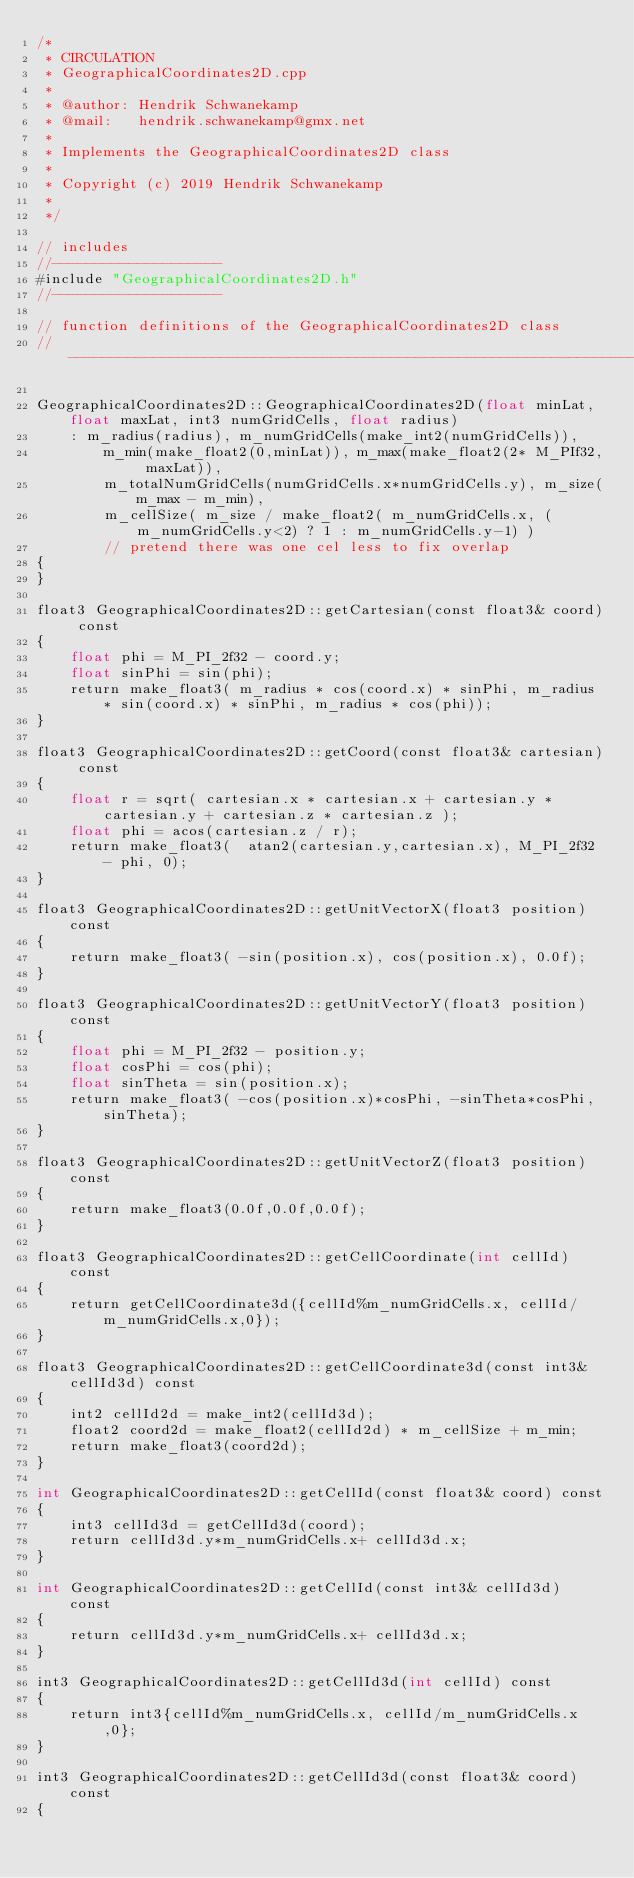Convert code to text. <code><loc_0><loc_0><loc_500><loc_500><_Cuda_>/*
 * CIRCULATION
 * GeographicalCoordinates2D.cpp
 *
 * @author: Hendrik Schwanekamp
 * @mail:   hendrik.schwanekamp@gmx.net
 *
 * Implements the GeographicalCoordinates2D class
 *
 * Copyright (c) 2019 Hendrik Schwanekamp
 *
 */

// includes
//--------------------
#include "GeographicalCoordinates2D.h"
//--------------------

// function definitions of the GeographicalCoordinates2D class
//-------------------------------------------------------------------

GeographicalCoordinates2D::GeographicalCoordinates2D(float minLat, float maxLat, int3 numGridCells, float radius)
    : m_radius(radius), m_numGridCells(make_int2(numGridCells)),
        m_min(make_float2(0,minLat)), m_max(make_float2(2* M_PIf32, maxLat)),
        m_totalNumGridCells(numGridCells.x*numGridCells.y), m_size(m_max - m_min),
        m_cellSize( m_size / make_float2( m_numGridCells.x, (m_numGridCells.y<2) ? 1 : m_numGridCells.y-1) )
        // pretend there was one cel less to fix overlap
{
}

float3 GeographicalCoordinates2D::getCartesian(const float3& coord) const
{
    float phi = M_PI_2f32 - coord.y;
    float sinPhi = sin(phi);
    return make_float3( m_radius * cos(coord.x) * sinPhi, m_radius * sin(coord.x) * sinPhi, m_radius * cos(phi));
}

float3 GeographicalCoordinates2D::getCoord(const float3& cartesian) const
{
    float r = sqrt( cartesian.x * cartesian.x + cartesian.y * cartesian.y + cartesian.z * cartesian.z );
    float phi = acos(cartesian.z / r);
    return make_float3(  atan2(cartesian.y,cartesian.x), M_PI_2f32 - phi, 0);
}

float3 GeographicalCoordinates2D::getUnitVectorX(float3 position) const
{
    return make_float3( -sin(position.x), cos(position.x), 0.0f);
}

float3 GeographicalCoordinates2D::getUnitVectorY(float3 position) const
{
    float phi = M_PI_2f32 - position.y;
    float cosPhi = cos(phi);
    float sinTheta = sin(position.x);
    return make_float3( -cos(position.x)*cosPhi, -sinTheta*cosPhi, sinTheta);
}

float3 GeographicalCoordinates2D::getUnitVectorZ(float3 position) const
{
    return make_float3(0.0f,0.0f,0.0f);
}

float3 GeographicalCoordinates2D::getCellCoordinate(int cellId) const
{
    return getCellCoordinate3d({cellId%m_numGridCells.x, cellId/m_numGridCells.x,0});
}

float3 GeographicalCoordinates2D::getCellCoordinate3d(const int3& cellId3d) const
{
    int2 cellId2d = make_int2(cellId3d);
    float2 coord2d = make_float2(cellId2d) * m_cellSize + m_min;
    return make_float3(coord2d);
}

int GeographicalCoordinates2D::getCellId(const float3& coord) const
{
    int3 cellId3d = getCellId3d(coord);
    return cellId3d.y*m_numGridCells.x+ cellId3d.x;
}

int GeographicalCoordinates2D::getCellId(const int3& cellId3d) const
{
    return cellId3d.y*m_numGridCells.x+ cellId3d.x;
}

int3 GeographicalCoordinates2D::getCellId3d(int cellId) const
{
    return int3{cellId%m_numGridCells.x, cellId/m_numGridCells.x,0};
}

int3 GeographicalCoordinates2D::getCellId3d(const float3& coord) const
{</code> 